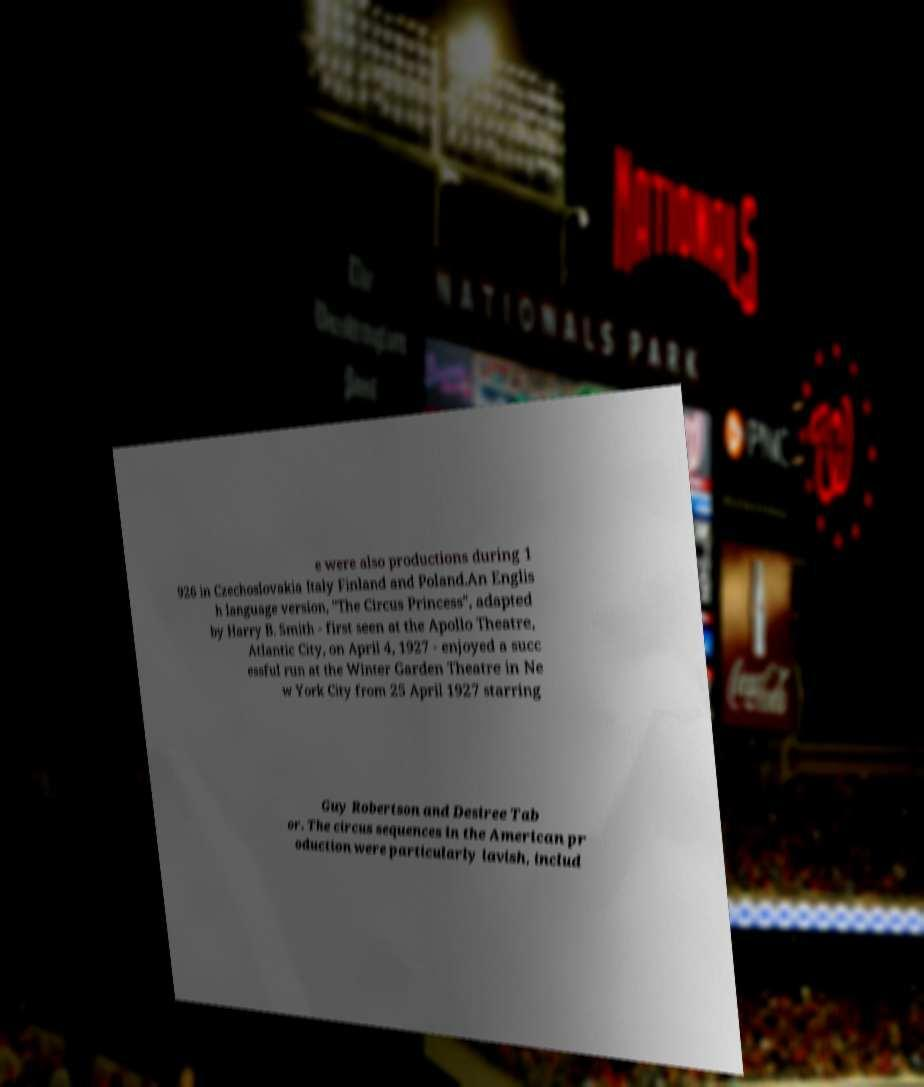For documentation purposes, I need the text within this image transcribed. Could you provide that? e were also productions during 1 926 in Czechoslovakia Italy Finland and Poland.An Englis h language version, "The Circus Princess", adapted by Harry B. Smith - first seen at the Apollo Theatre, Atlantic City, on April 4, 1927 - enjoyed a succ essful run at the Winter Garden Theatre in Ne w York City from 25 April 1927 starring Guy Robertson and Desiree Tab or. The circus sequences in the American pr oduction were particularly lavish, includ 